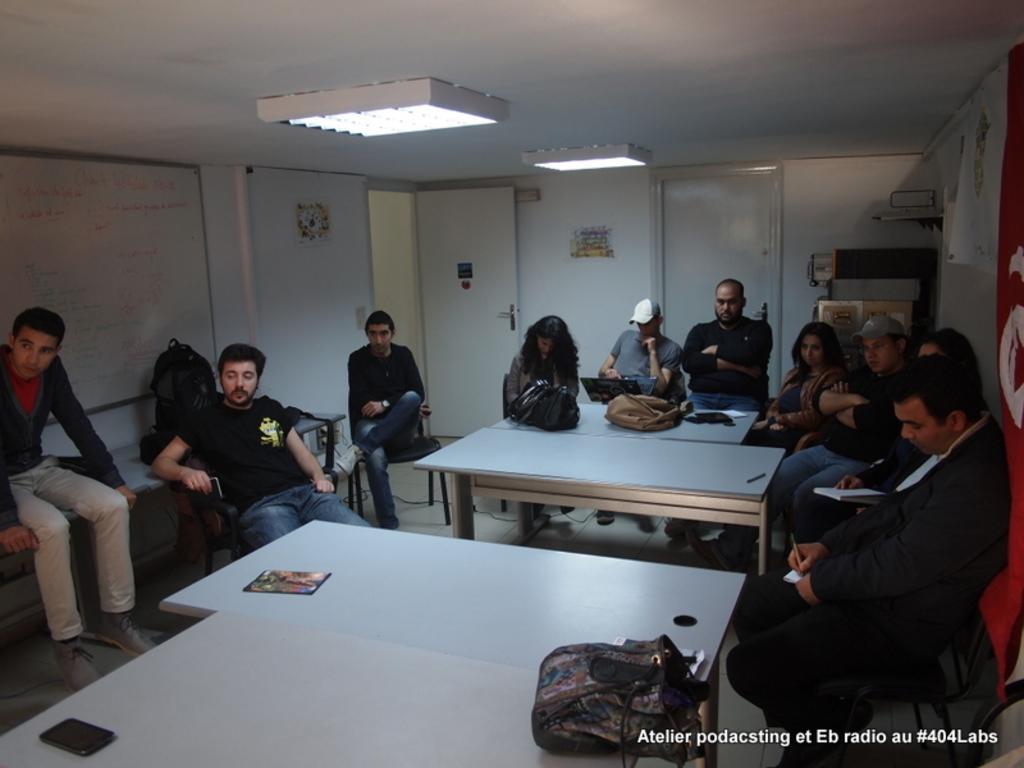Please provide a concise description of this image. In the image we can see there are people who are sitting on chair. 